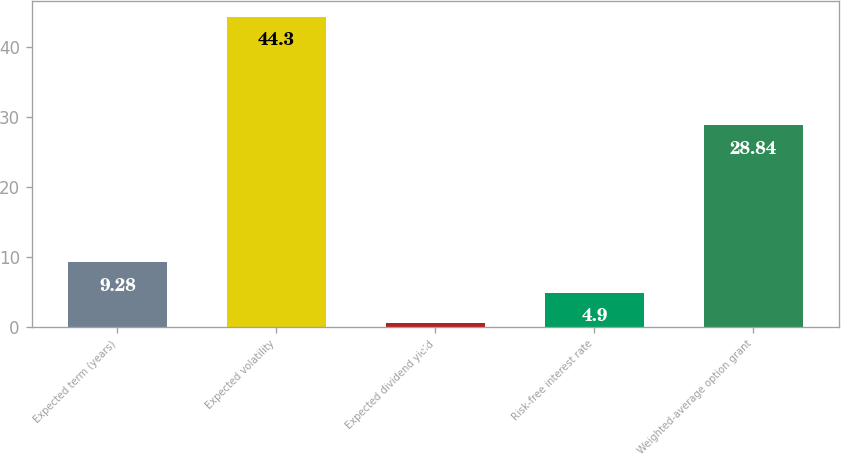Convert chart. <chart><loc_0><loc_0><loc_500><loc_500><bar_chart><fcel>Expected term (years)<fcel>Expected volatility<fcel>Expected dividend yield<fcel>Risk-free interest rate<fcel>Weighted-average option grant<nl><fcel>9.28<fcel>44.3<fcel>0.52<fcel>4.9<fcel>28.84<nl></chart> 